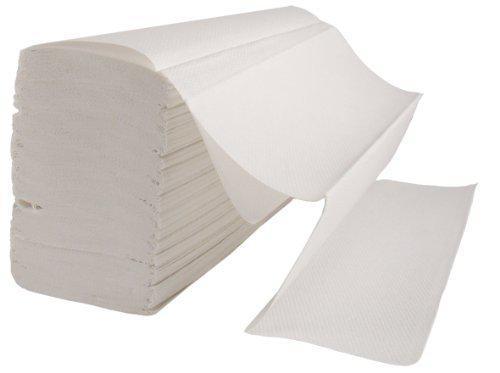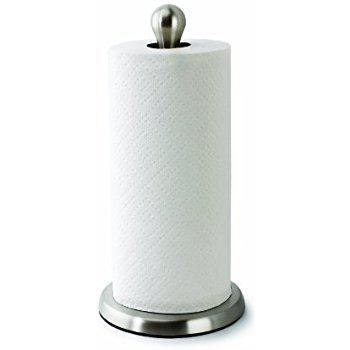The first image is the image on the left, the second image is the image on the right. Examine the images to the left and right. Is the description "A towel roll is held vertically on a stand with a silver base." accurate? Answer yes or no. Yes. 